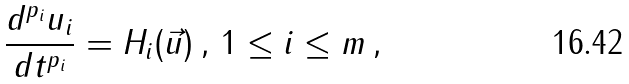<formula> <loc_0><loc_0><loc_500><loc_500>\frac { d ^ { p _ { i } } u _ { i } } { d t ^ { p _ { i } } } = H _ { i } ( \vec { u } ) \, , \, 1 \leq i \leq m \, ,</formula> 